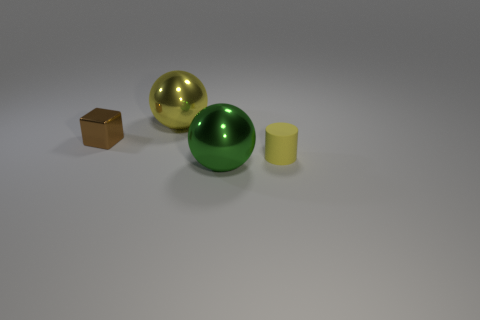There is a big yellow shiny thing that is right of the block; is its shape the same as the tiny brown object?
Offer a terse response. No. How many rubber objects are tiny brown blocks or large balls?
Your response must be concise. 0. Are there any other big things made of the same material as the big green thing?
Provide a succinct answer. Yes. What is the material of the small yellow cylinder?
Keep it short and to the point. Rubber. There is a yellow object that is to the right of the large ball behind the small brown shiny thing behind the small yellow cylinder; what shape is it?
Provide a succinct answer. Cylinder. Are there more big yellow balls on the left side of the small brown metallic cube than gray metal spheres?
Offer a very short reply. No. There is a brown thing; does it have the same shape as the yellow thing to the left of the cylinder?
Provide a succinct answer. No. What shape is the large metal object that is the same color as the tiny rubber cylinder?
Provide a succinct answer. Sphere. What number of tiny brown metal blocks are in front of the large metal thing that is to the left of the large sphere in front of the yellow matte cylinder?
Provide a short and direct response. 1. What color is the metallic block that is the same size as the rubber thing?
Make the answer very short. Brown. 